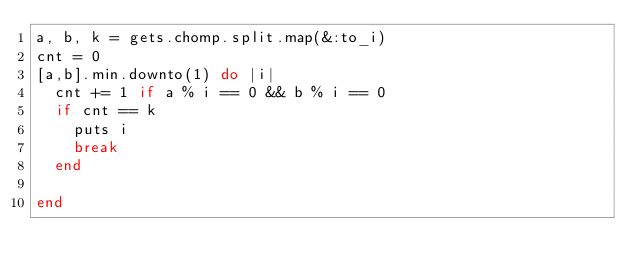<code> <loc_0><loc_0><loc_500><loc_500><_Ruby_>a, b, k = gets.chomp.split.map(&:to_i)
cnt = 0
[a,b].min.downto(1) do |i|
	cnt += 1 if a % i == 0 && b % i == 0
	if cnt == k
		puts i
		break
	end

end


</code> 